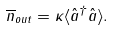Convert formula to latex. <formula><loc_0><loc_0><loc_500><loc_500>\overline { n } _ { o u t } = \kappa \langle \hat { a } ^ { \dagger } \hat { a } \rangle .</formula> 